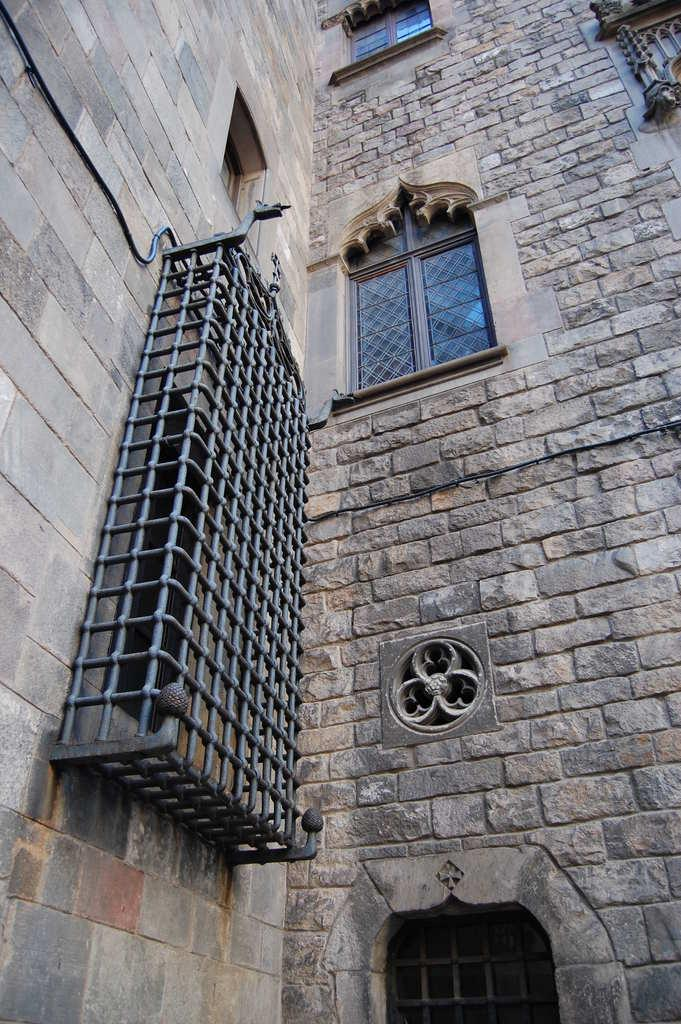What type of structure is in the image? There is a building in the image. What material is used for the walls of the building? The building has stone walls. What architectural features can be seen on the building? The building has windows and a grill. How does the building contribute to pollution in the image? The image does not provide any information about pollution, and there is no indication that the building contributes to pollution. 